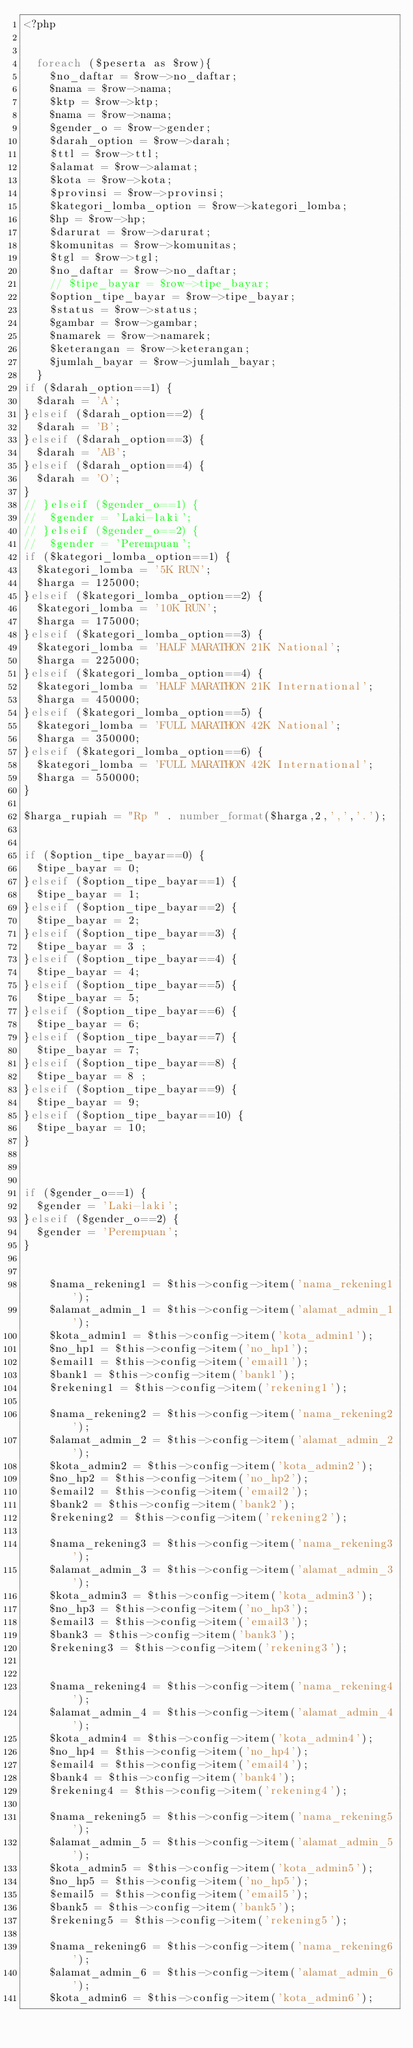<code> <loc_0><loc_0><loc_500><loc_500><_PHP_><?php

 
  foreach ($peserta as $row){
    $no_daftar = $row->no_daftar;
    $nama = $row->nama;
    $ktp = $row->ktp;
    $nama = $row->nama;
    $gender_o = $row->gender;
    $darah_option = $row->darah;
    $ttl = $row->ttl;
    $alamat = $row->alamat;
    $kota = $row->kota;
    $provinsi = $row->provinsi;
    $kategori_lomba_option = $row->kategori_lomba;
    $hp = $row->hp;
    $darurat = $row->darurat;
    $komunitas = $row->komunitas;
    $tgl = $row->tgl;
    $no_daftar = $row->no_daftar;
    // $tipe_bayar = $row->tipe_bayar;
    $option_tipe_bayar = $row->tipe_bayar;
    $status = $row->status;
    $gambar = $row->gambar;
    $namarek = $row->namarek;
    $keterangan = $row->keterangan;
    $jumlah_bayar = $row->jumlah_bayar;
  } 
if ($darah_option==1) {
  $darah = 'A';
}elseif ($darah_option==2) {
  $darah = 'B'; 
}elseif ($darah_option==3) {
  $darah = 'AB'; 
}elseif ($darah_option==4) {
  $darah = 'O';
} 
// }elseif ($gender_o==1) {
//  $gender = 'Laki-laki'; 
// }elseif ($gender_o==2) {
//  $gender = 'Perempuan'; 
if ($kategori_lomba_option==1) {
  $kategori_lomba = '5K RUN';
  $harga = 125000; 
}elseif ($kategori_lomba_option==2) {
  $kategori_lomba = '10K RUN'; 
  $harga = 175000; 
}elseif ($kategori_lomba_option==3) {
  $kategori_lomba = 'HALF MARATHON 21K National'; 
  $harga = 225000; 
}elseif ($kategori_lomba_option==4) {
  $kategori_lomba = 'HALF MARATHON 21K International'; 
  $harga = 450000; 
}elseif ($kategori_lomba_option==5) {
  $kategori_lomba = 'FULL MARATHON 42K National';
  $harga = 350000; 
}elseif ($kategori_lomba_option==6) {
  $kategori_lomba = 'FULL MARATHON 42K International';
  $harga = 550000; 
}

$harga_rupiah = "Rp " . number_format($harga,2,',','.');


if ($option_tipe_bayar==0) {
  $tipe_bayar = 0; 
}elseif ($option_tipe_bayar==1) {
  $tipe_bayar = 1; 
}elseif ($option_tipe_bayar==2) {
  $tipe_bayar = 2; 
}elseif ($option_tipe_bayar==3) {
  $tipe_bayar = 3 ; 
}elseif ($option_tipe_bayar==4) {
  $tipe_bayar = 4; 
}elseif ($option_tipe_bayar==5) {
  $tipe_bayar = 5; 
}elseif ($option_tipe_bayar==6) {
  $tipe_bayar = 6; 
}elseif ($option_tipe_bayar==7) {
  $tipe_bayar = 7; 
}elseif ($option_tipe_bayar==8) {
  $tipe_bayar = 8 ;  
}elseif ($option_tipe_bayar==9) {
  $tipe_bayar = 9; 
}elseif ($option_tipe_bayar==10) {
  $tipe_bayar = 10; 
}
 


if ($gender_o==1) {
  $gender = 'Laki-laki'; 
}elseif ($gender_o==2) {
  $gender = 'Perempuan'; 
}

    
    $nama_rekening1 = $this->config->item('nama_rekening1');
    $alamat_admin_1 = $this->config->item('alamat_admin_1');  
    $kota_admin1 = $this->config->item('kota_admin1'); 
    $no_hp1 = $this->config->item('no_hp1'); 
    $email1 = $this->config->item('email1'); 
    $bank1 = $this->config->item('bank1'); 
    $rekening1 = $this->config->item('rekening1'); 
    
    $nama_rekening2 = $this->config->item('nama_rekening2');
    $alamat_admin_2 = $this->config->item('alamat_admin_2'); 
    $kota_admin2 = $this->config->item('kota_admin2'); 
    $no_hp2 = $this->config->item('no_hp2'); 
    $email2 = $this->config->item('email2'); 
    $bank2 = $this->config->item('bank2'); 
    $rekening2 = $this->config->item('rekening2');

    $nama_rekening3 = $this->config->item('nama_rekening3');
    $alamat_admin_3 = $this->config->item('alamat_admin_3'); 
    $kota_admin3 = $this->config->item('kota_admin3'); 
    $no_hp3 = $this->config->item('no_hp3'); 
    $email3 = $this->config->item('email3'); 
    $bank3 = $this->config->item('bank3'); 
    $rekening3 = $this->config->item('rekening3');


    $nama_rekening4 = $this->config->item('nama_rekening4');
    $alamat_admin_4 = $this->config->item('alamat_admin_4'); 
    $kota_admin4 = $this->config->item('kota_admin4'); 
    $no_hp4 = $this->config->item('no_hp4'); 
    $email4 = $this->config->item('email4'); 
    $bank4 = $this->config->item('bank4'); 
    $rekening4 = $this->config->item('rekening4');

    $nama_rekening5 = $this->config->item('nama_rekening5');
    $alamat_admin_5 = $this->config->item('alamat_admin_5'); 
    $kota_admin5 = $this->config->item('kota_admin5'); 
    $no_hp5 = $this->config->item('no_hp5'); 
    $email5 = $this->config->item('email5'); 
    $bank5 = $this->config->item('bank5'); 
    $rekening5 = $this->config->item('rekening5');

    $nama_rekening6 = $this->config->item('nama_rekening6');
    $alamat_admin_6 = $this->config->item('alamat_admin_6');  
    $kota_admin6 = $this->config->item('kota_admin6'); </code> 